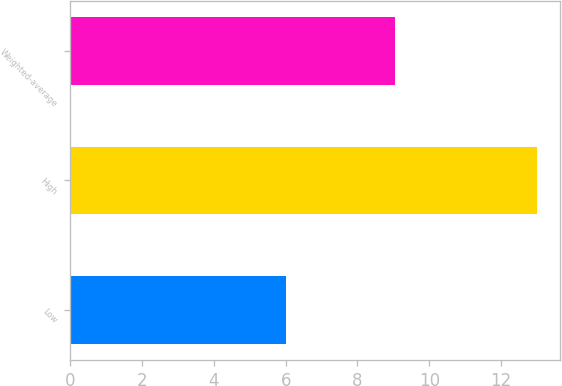Convert chart. <chart><loc_0><loc_0><loc_500><loc_500><bar_chart><fcel>Low<fcel>High<fcel>Weighted-average<nl><fcel>6<fcel>13<fcel>9.05<nl></chart> 